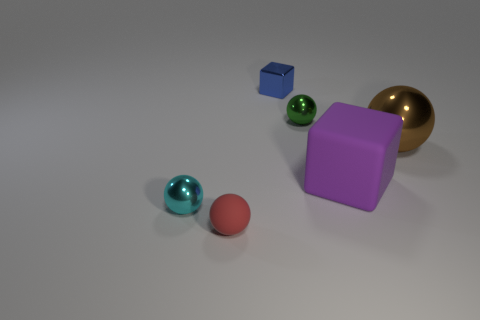How many objects are either green shiny blocks or big purple blocks?
Your response must be concise. 1. What is the material of the ball on the right side of the green sphere right of the tiny metallic thing behind the green sphere?
Provide a succinct answer. Metal. What material is the cube that is behind the tiny green shiny ball?
Ensure brevity in your answer.  Metal. Is there a purple ball of the same size as the purple rubber object?
Your answer should be very brief. No. Is the color of the ball on the right side of the large purple matte cube the same as the big matte thing?
Keep it short and to the point. No. How many blue things are small metal cubes or big blocks?
Your answer should be very brief. 1. Is the material of the brown sphere the same as the tiny blue block?
Make the answer very short. Yes. How many metal objects are to the right of the metallic ball to the left of the red object?
Provide a short and direct response. 3. Is the blue thing the same size as the purple object?
Give a very brief answer. No. What number of purple blocks are made of the same material as the red sphere?
Offer a terse response. 1. 